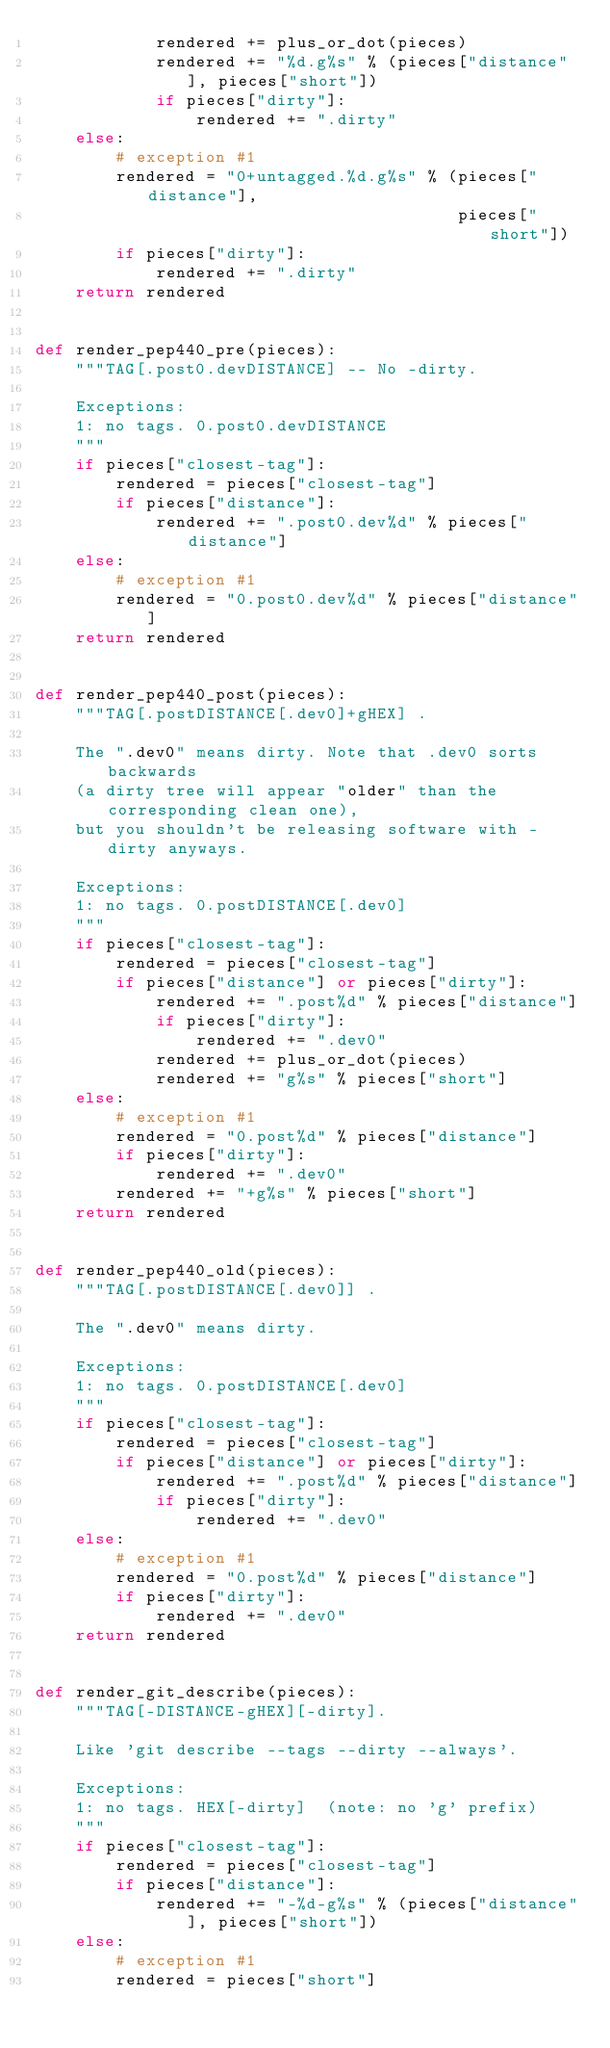<code> <loc_0><loc_0><loc_500><loc_500><_Python_>            rendered += plus_or_dot(pieces)
            rendered += "%d.g%s" % (pieces["distance"], pieces["short"])
            if pieces["dirty"]:
                rendered += ".dirty"
    else:
        # exception #1
        rendered = "0+untagged.%d.g%s" % (pieces["distance"],
                                          pieces["short"])
        if pieces["dirty"]:
            rendered += ".dirty"
    return rendered


def render_pep440_pre(pieces):
    """TAG[.post0.devDISTANCE] -- No -dirty.

    Exceptions:
    1: no tags. 0.post0.devDISTANCE
    """
    if pieces["closest-tag"]:
        rendered = pieces["closest-tag"]
        if pieces["distance"]:
            rendered += ".post0.dev%d" % pieces["distance"]
    else:
        # exception #1
        rendered = "0.post0.dev%d" % pieces["distance"]
    return rendered


def render_pep440_post(pieces):
    """TAG[.postDISTANCE[.dev0]+gHEX] .

    The ".dev0" means dirty. Note that .dev0 sorts backwards
    (a dirty tree will appear "older" than the corresponding clean one),
    but you shouldn't be releasing software with -dirty anyways.

    Exceptions:
    1: no tags. 0.postDISTANCE[.dev0]
    """
    if pieces["closest-tag"]:
        rendered = pieces["closest-tag"]
        if pieces["distance"] or pieces["dirty"]:
            rendered += ".post%d" % pieces["distance"]
            if pieces["dirty"]:
                rendered += ".dev0"
            rendered += plus_or_dot(pieces)
            rendered += "g%s" % pieces["short"]
    else:
        # exception #1
        rendered = "0.post%d" % pieces["distance"]
        if pieces["dirty"]:
            rendered += ".dev0"
        rendered += "+g%s" % pieces["short"]
    return rendered


def render_pep440_old(pieces):
    """TAG[.postDISTANCE[.dev0]] .

    The ".dev0" means dirty.

    Exceptions:
    1: no tags. 0.postDISTANCE[.dev0]
    """
    if pieces["closest-tag"]:
        rendered = pieces["closest-tag"]
        if pieces["distance"] or pieces["dirty"]:
            rendered += ".post%d" % pieces["distance"]
            if pieces["dirty"]:
                rendered += ".dev0"
    else:
        # exception #1
        rendered = "0.post%d" % pieces["distance"]
        if pieces["dirty"]:
            rendered += ".dev0"
    return rendered


def render_git_describe(pieces):
    """TAG[-DISTANCE-gHEX][-dirty].

    Like 'git describe --tags --dirty --always'.

    Exceptions:
    1: no tags. HEX[-dirty]  (note: no 'g' prefix)
    """
    if pieces["closest-tag"]:
        rendered = pieces["closest-tag"]
        if pieces["distance"]:
            rendered += "-%d-g%s" % (pieces["distance"], pieces["short"])
    else:
        # exception #1
        rendered = pieces["short"]</code> 